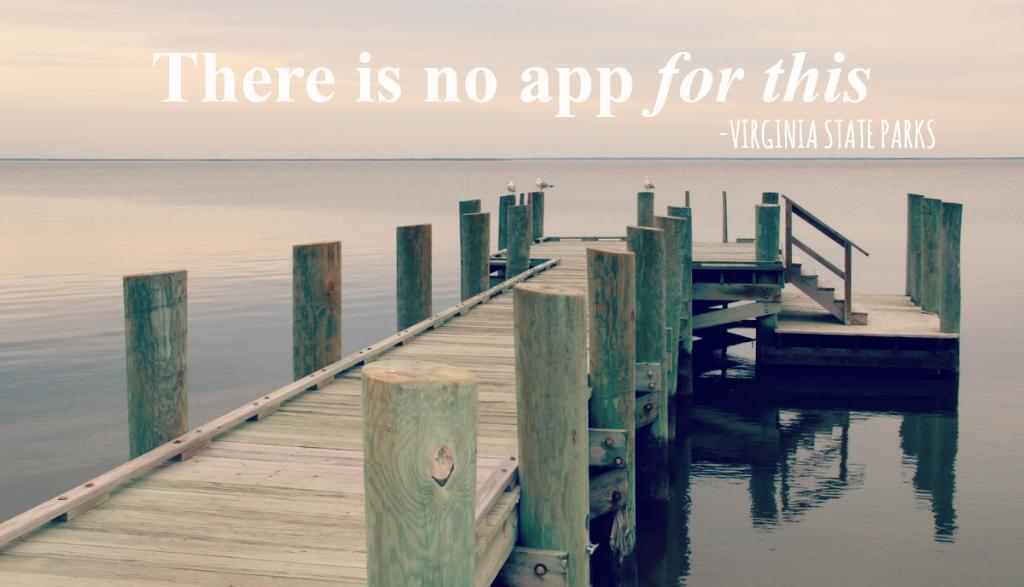Describe this image in one or two sentences. In this image we can see a deck with wooden poles. Also there are steps with railing. And there is water. At the top something is written on the image. 